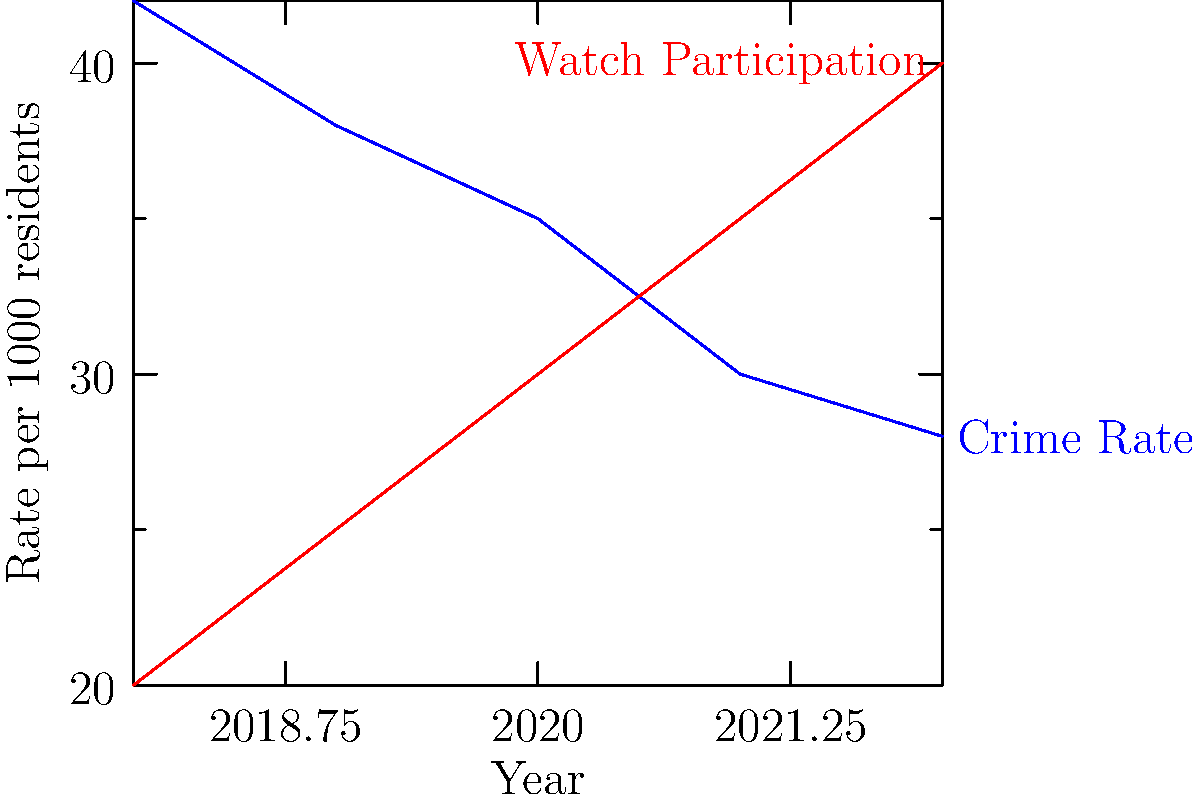Based on the line graph showing crime rates and neighborhood watch participation from 2018 to 2022, what is the correlation coefficient between these two variables, rounded to two decimal places? To calculate the correlation coefficient between crime rates and neighborhood watch participation:

1. Calculate the means:
   Crime rate mean ($\bar{x}$) = $(42 + 38 + 35 + 30 + 28) / 5 = 34.6$
   Watch participation mean ($\bar{y}$) = $(20 + 25 + 30 + 35 + 40) / 5 = 30$

2. Calculate deviations from the mean:
   Crime rate: $(7.4, 3.4, 0.4, -4.6, -6.6)$
   Watch participation: $(-10, -5, 0, 5, 10)$

3. Multiply corresponding deviations:
   $(-74, -17, 0, -23, -66)$

4. Sum of multiplied deviations:
   $\sum (x_i - \bar{x})(y_i - \bar{y}) = -180$

5. Calculate standard deviations:
   $s_x = \sqrt{\frac{\sum (x_i - \bar{x})^2}{n-1}} = 5.94$
   $s_y = \sqrt{\frac{\sum (y_i - \bar{y})^2}{n-1}} = 7.91$

6. Apply the correlation coefficient formula:
   $r = \frac{\sum (x_i - \bar{x})(y_i - \bar{y})}{(n-1)s_x s_y}$
   
   $r = \frac{-180}{(5-1)(5.94)(7.91)} = -0.9598$

7. Round to two decimal places: $-0.96$
Answer: $-0.96$ 